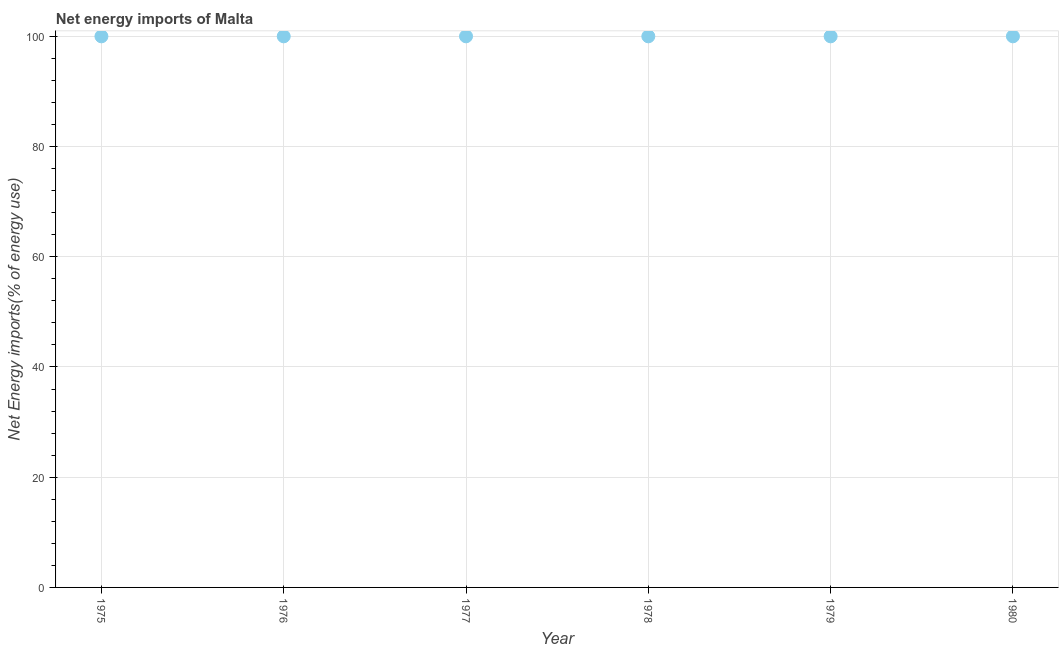What is the energy imports in 1979?
Keep it short and to the point. 100. In which year was the energy imports maximum?
Keep it short and to the point. 1975. In which year was the energy imports minimum?
Give a very brief answer. 1975. What is the sum of the energy imports?
Keep it short and to the point. 600. Do a majority of the years between 1975 and 1977 (inclusive) have energy imports greater than 8 %?
Your answer should be very brief. Yes. Is the difference between the energy imports in 1977 and 1979 greater than the difference between any two years?
Give a very brief answer. Yes. Is the sum of the energy imports in 1977 and 1979 greater than the maximum energy imports across all years?
Offer a terse response. Yes. What is the difference between the highest and the lowest energy imports?
Ensure brevity in your answer.  0. In how many years, is the energy imports greater than the average energy imports taken over all years?
Offer a very short reply. 0. Does the energy imports monotonically increase over the years?
Keep it short and to the point. No. What is the difference between two consecutive major ticks on the Y-axis?
Offer a terse response. 20. Are the values on the major ticks of Y-axis written in scientific E-notation?
Give a very brief answer. No. Does the graph contain any zero values?
Make the answer very short. No. What is the title of the graph?
Provide a short and direct response. Net energy imports of Malta. What is the label or title of the X-axis?
Provide a succinct answer. Year. What is the label or title of the Y-axis?
Provide a short and direct response. Net Energy imports(% of energy use). What is the Net Energy imports(% of energy use) in 1975?
Keep it short and to the point. 100. What is the Net Energy imports(% of energy use) in 1977?
Keep it short and to the point. 100. What is the Net Energy imports(% of energy use) in 1978?
Keep it short and to the point. 100. What is the Net Energy imports(% of energy use) in 1979?
Your answer should be very brief. 100. What is the difference between the Net Energy imports(% of energy use) in 1975 and 1978?
Offer a very short reply. 0. What is the difference between the Net Energy imports(% of energy use) in 1976 and 1977?
Your answer should be very brief. 0. What is the difference between the Net Energy imports(% of energy use) in 1976 and 1979?
Your response must be concise. 0. What is the difference between the Net Energy imports(% of energy use) in 1979 and 1980?
Offer a very short reply. 0. What is the ratio of the Net Energy imports(% of energy use) in 1975 to that in 1977?
Provide a succinct answer. 1. What is the ratio of the Net Energy imports(% of energy use) in 1975 to that in 1979?
Your answer should be very brief. 1. What is the ratio of the Net Energy imports(% of energy use) in 1975 to that in 1980?
Provide a short and direct response. 1. What is the ratio of the Net Energy imports(% of energy use) in 1976 to that in 1980?
Offer a terse response. 1. What is the ratio of the Net Energy imports(% of energy use) in 1977 to that in 1980?
Keep it short and to the point. 1. What is the ratio of the Net Energy imports(% of energy use) in 1978 to that in 1980?
Offer a terse response. 1. 